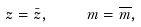<formula> <loc_0><loc_0><loc_500><loc_500>z = \bar { z } , \quad m = \overline { m } ,</formula> 